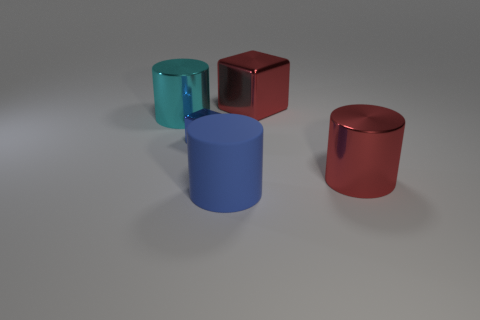What shape is the red object that is the same size as the red cylinder?
Keep it short and to the point. Cube. Is there another blue rubber thing that has the same shape as the big matte object?
Give a very brief answer. No. What number of red cylinders have the same material as the blue cube?
Your answer should be compact. 1. Does the cube that is in front of the big cyan shiny thing have the same material as the big blue object?
Make the answer very short. No. Is the number of tiny blue objects to the right of the rubber thing greater than the number of large red things to the left of the red metal cube?
Give a very brief answer. No. There is a cyan cylinder that is the same size as the red shiny cube; what is it made of?
Offer a terse response. Metal. How many other objects are there of the same material as the red cylinder?
Your response must be concise. 3. There is a blue thing that is to the left of the large rubber thing; does it have the same shape as the big red shiny thing right of the big metal cube?
Provide a succinct answer. No. How many other objects are there of the same color as the rubber cylinder?
Give a very brief answer. 1. Is the red object that is behind the blue cube made of the same material as the big cylinder left of the tiny blue block?
Your answer should be compact. Yes. 